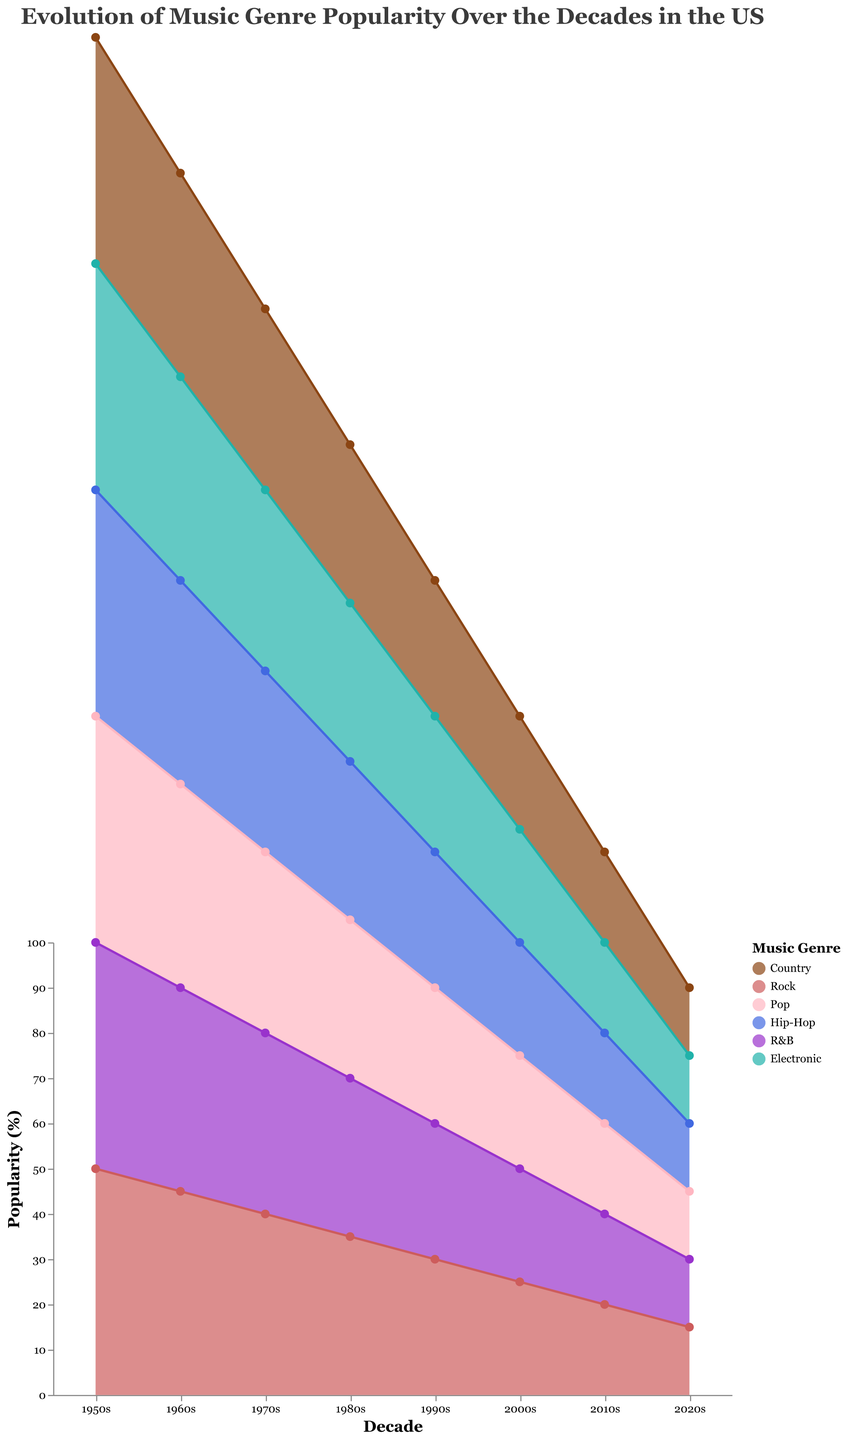What is the title of the chart? The title is at the top of the chart and it reads "Evolution of Music Genre Popularity Over the Decades in the US".
Answer: Evolution of Music Genre Popularity Over the Decades in the US Which genre had the highest popularity in the 1950s? By looking at the height of the area representing each genre in the decade of the 1950s, the Country genre has the highest popularity with a value of 50%.
Answer: Country How did the popularity of Rock change from the 1960s to the 2020s? In the 1960s, Rock has a popularity of 25%. In the 2020s, its popularity is 20%. Subtracting these gives us a decrease of 5%.
Answer: Decreased by 5% Which genre achieved the highest popularity in the 2020s? By analyzing the areas for each genre in the 2020s, the Electronic genre is the highest with a popularity of 55%.
Answer: Electronic Compare the popularity of Pop and Hip-Hop in the 2010s. In the 2010s, Pop has a popularity of 30% and Hip-Hop has a popularity of 20%. Pop is more popular by 10%.
Answer: Pop is more popular by 10% What is the overall trend of the Country genre over the decades? By following the area representing Country from the 1950s (50%) to the 2020s (15%), the popularity of Country continuously decreases over time.
Answer: Decreasing trend By how much did the popularity of Electronic increase from the 1980s to the 2020s? In the 1980s, Electronic has a popularity of 20%, and in the 2020s, it has 55%. Subtracting these gives an increase of 35%.
Answer: Increased by 35% Which decade had the highest combined popularity of Country and Rock? Sum the popularity of Country and Rock for each decade: 
- 1950s: 50 + 10 = 60
- 1960s: 45 + 25 = 70
- 1970s: 40 + 30 = 70
- 1980s: 35 + 40 = 75
- 1990s: 30 + 35 = 65
- 2000s: 25 + 30 = 55
- 2010s: 20 + 25 = 45
- 2020s: 15 + 20 = 35
The 1980s had the highest combined popularity of 75%.
Answer: 1980s Which genre shows the most consistent popularity trend through the decades? By examining the line and area representation for each genre over the decades:
- Country decreases steadily.
- Rock fluctuates but mostly decreases.
- Pop increases.
- Hip-Hop increases.
- R&B increases.
- Electronic increases.
The Electronic genre shows a consistent increase in popularity.
Answer: Electronic Are there any genres that had an equal popularity percentage in any given decade? Evaluate each decade for percentages: In the 1960s, Hip-Hop and R&B both have a popularity of 5%.
Answer: Hip-Hop and R&B in the 1960s 